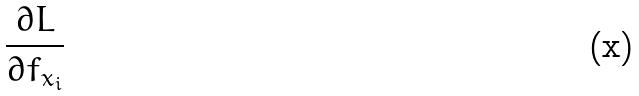Convert formula to latex. <formula><loc_0><loc_0><loc_500><loc_500>\frac { \partial L } { \partial f _ { x _ { i } } }</formula> 